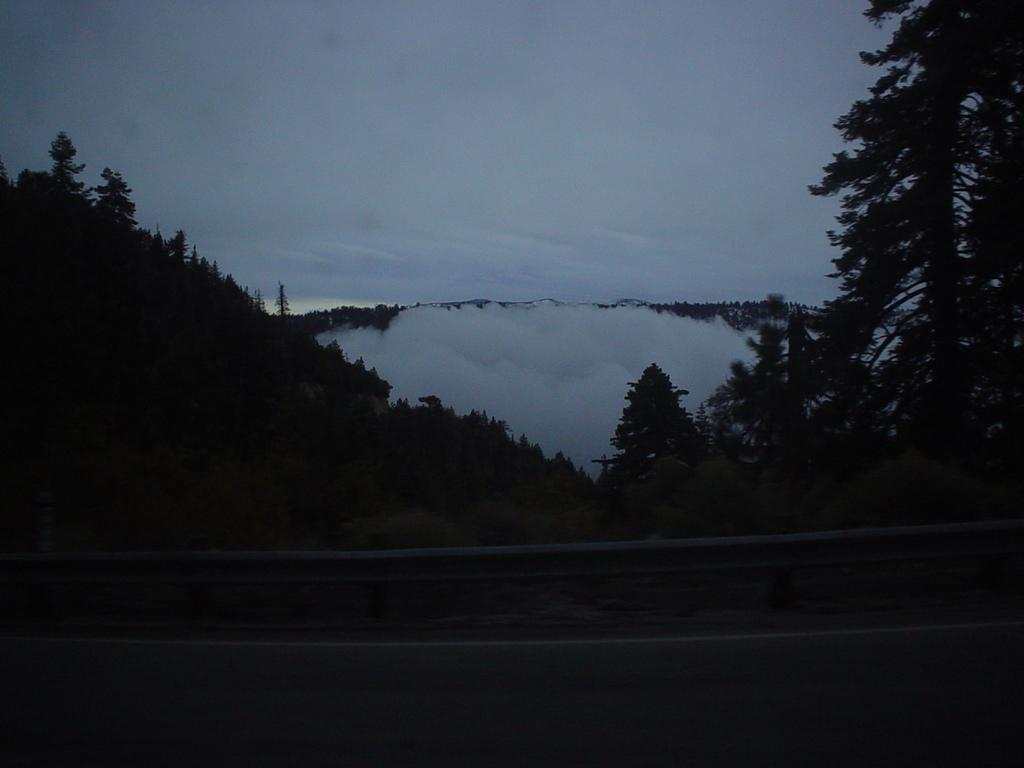What type of vegetation can be seen on the mountain in the image? There are trees on the mountain in the image. What is visible at the top of the image? The sky is visible at the top of the image. What can be seen in the sky? There are clouds in the sky. What is located at the bottom of the image? There is a road at the bottom of the image. What feature is present beside the road? There is a railing beside the road. How many planes can be seen on the sand in the image? There are no planes or sand present in the image. What type of street is visible in the image? There is no street visible in the image; it features a road and a railing. 